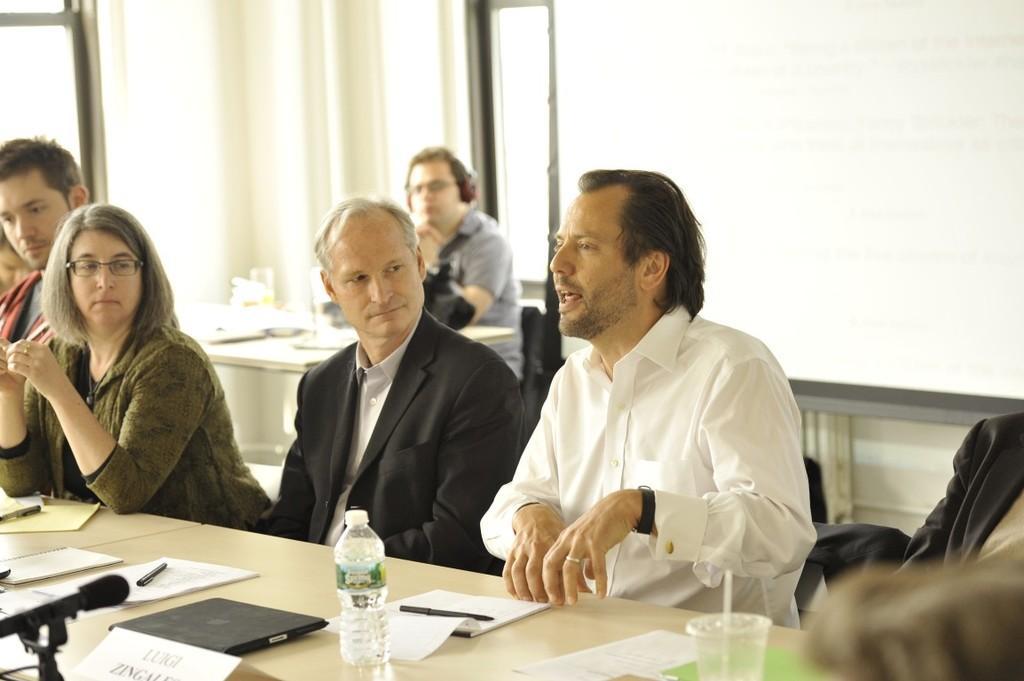Can you describe this image briefly? There are people sitting on the chair. The man in the white shirt is talking. There is a table. There is a bottle, a pen and a book on the table. There is a mic on the left side. In the background there is a window. 